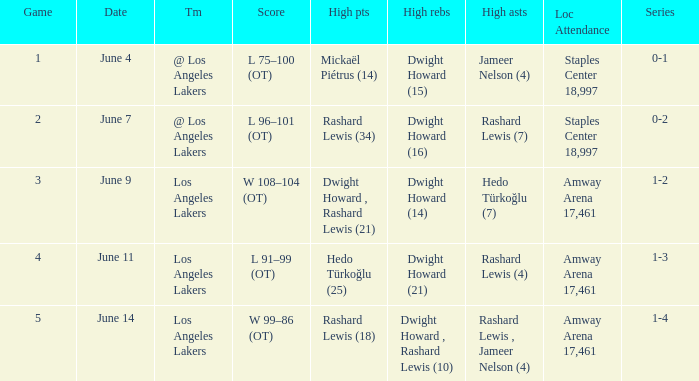What is Team, when High Assists is "Rashard Lewis (4)"? Los Angeles Lakers. 